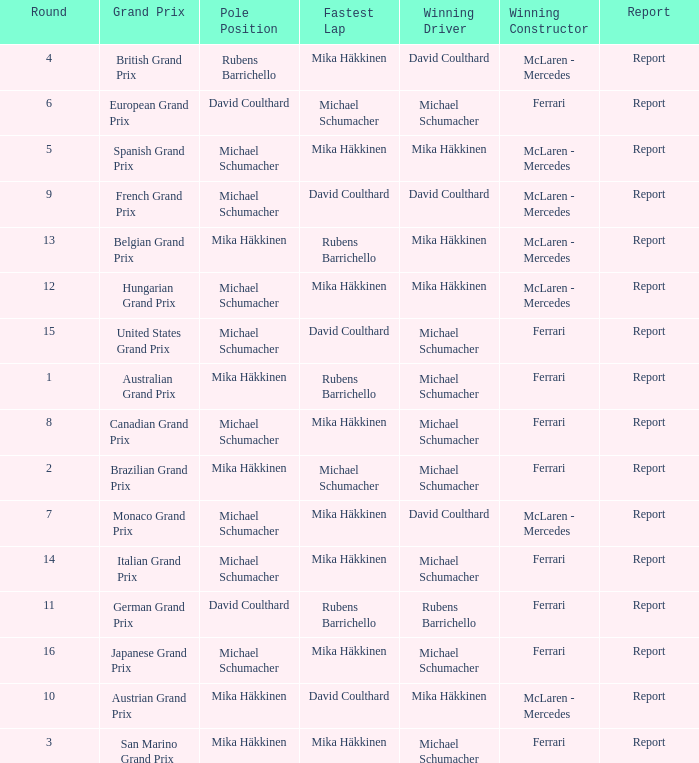What was the report of the Belgian Grand Prix? Report. 